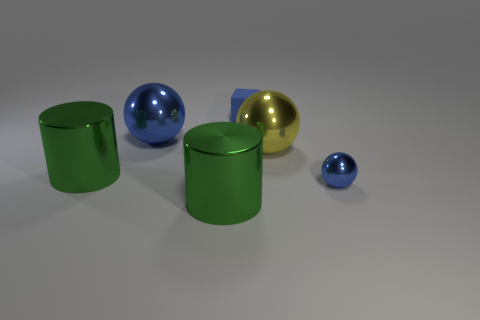Subtract all brown cylinders. How many blue balls are left? 2 Subtract all tiny balls. How many balls are left? 2 Add 2 green cylinders. How many objects exist? 8 Subtract all blocks. How many objects are left? 5 Add 5 yellow metallic things. How many yellow metallic things are left? 6 Add 6 tiny yellow metal cylinders. How many tiny yellow metal cylinders exist? 6 Subtract 0 green balls. How many objects are left? 6 Subtract all tiny rubber objects. Subtract all big yellow metal objects. How many objects are left? 4 